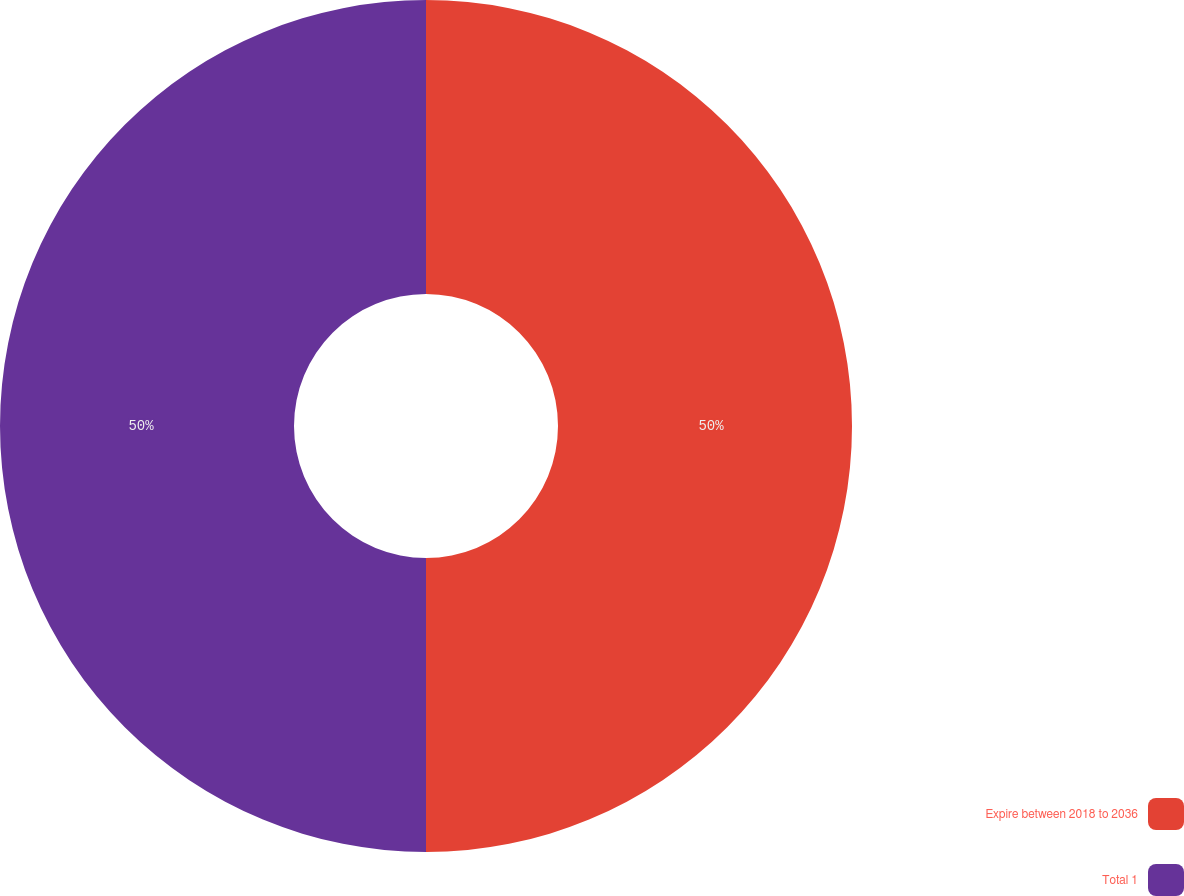Convert chart to OTSL. <chart><loc_0><loc_0><loc_500><loc_500><pie_chart><fcel>Expire between 2018 to 2036<fcel>Total 1<nl><fcel>50.0%<fcel>50.0%<nl></chart> 